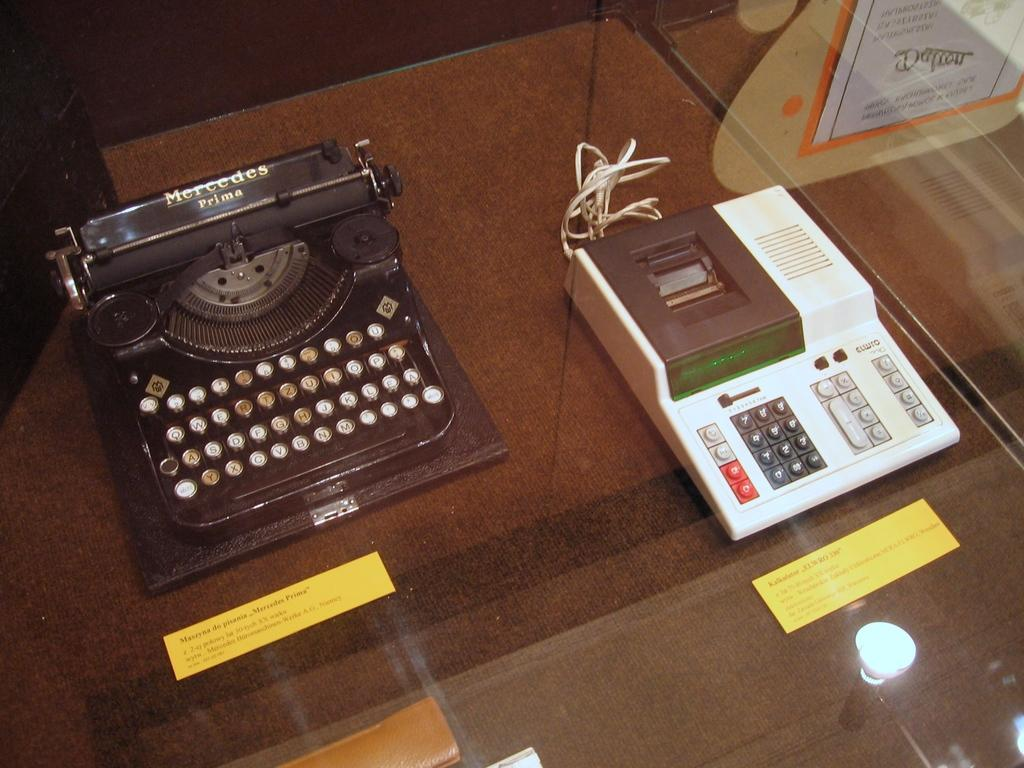<image>
Relay a brief, clear account of the picture shown. 2 old type writers with the first one being a Mercedes Prima. 